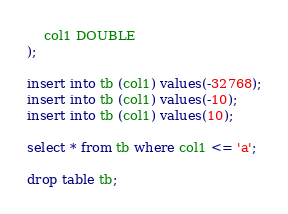<code> <loc_0><loc_0><loc_500><loc_500><_SQL_>	col1 DOUBLE
);

insert into tb (col1) values(-32768);
insert into tb (col1) values(-10);
insert into tb (col1) values(10);

select * from tb where col1 <= 'a';

drop table tb;

</code> 